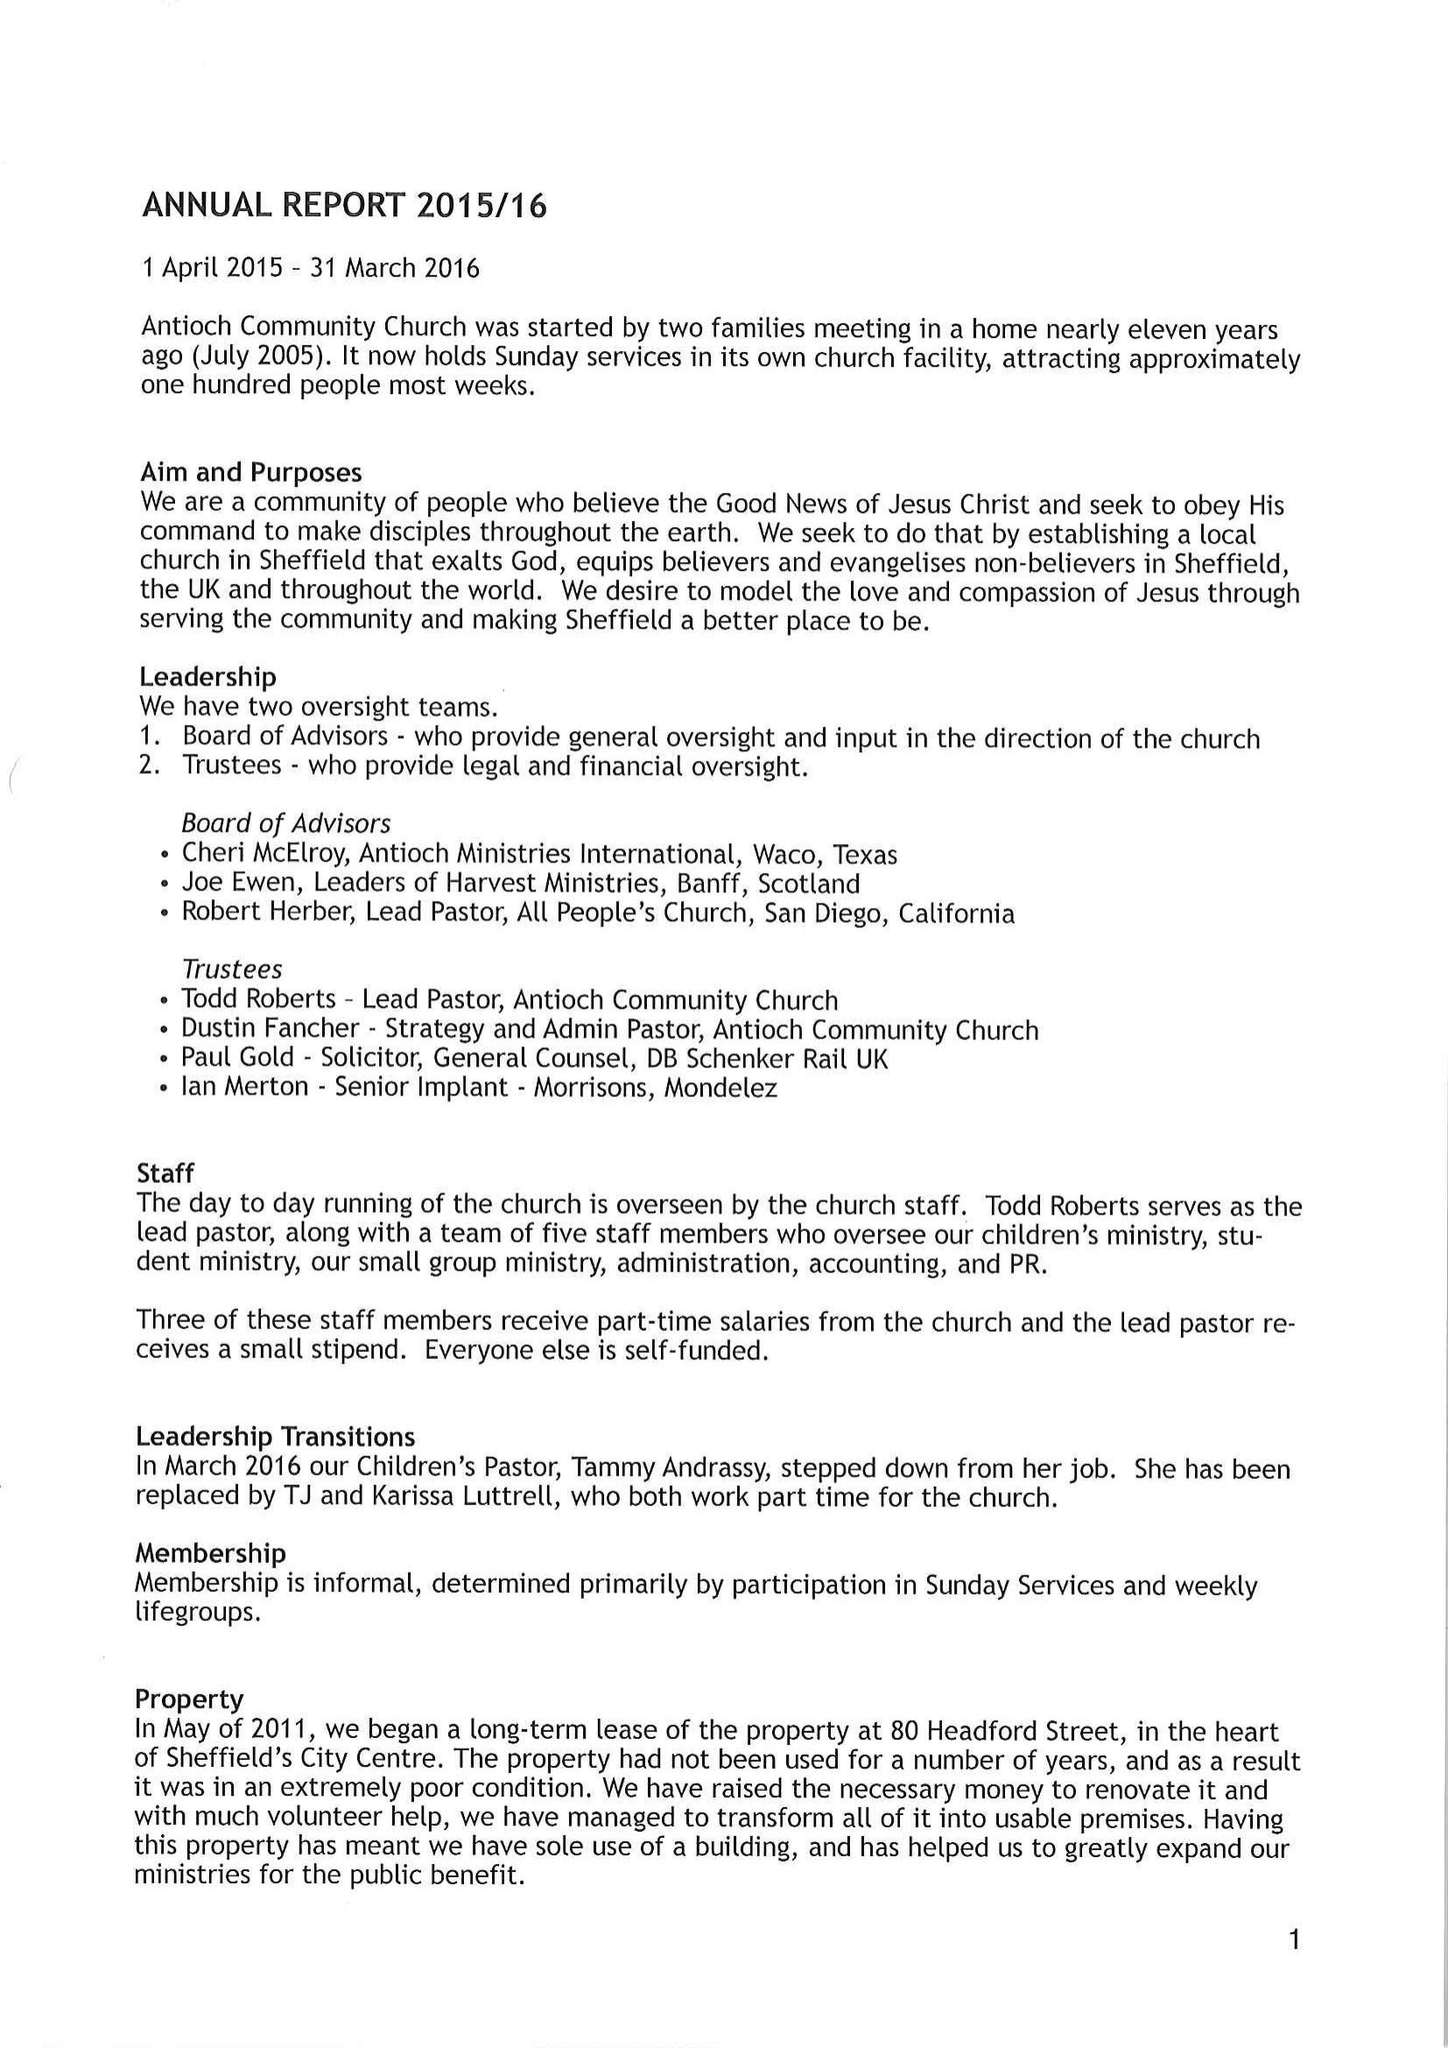What is the value for the address__street_line?
Answer the question using a single word or phrase. None 